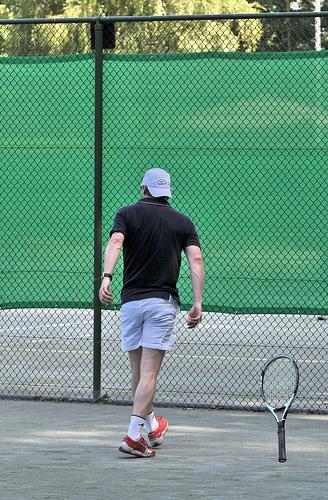Is that tennis racket floating?
Answer briefly. No. What sport is this man playing?
Quick response, please. Tennis. What color shirt is this person wearing?
Quick response, please. Black. 